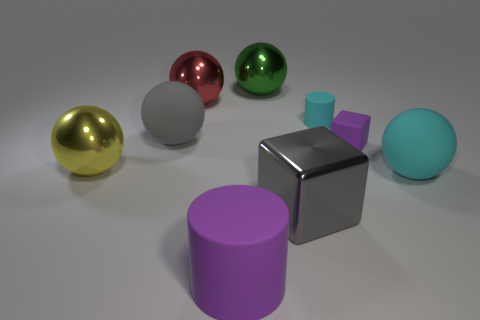Subtract all large yellow metallic balls. How many balls are left? 4 Subtract 3 spheres. How many spheres are left? 2 Subtract all cyan spheres. How many spheres are left? 4 Subtract all yellow balls. Subtract all gray cubes. How many balls are left? 4 Subtract all large cyan rubber spheres. Subtract all cyan cylinders. How many objects are left? 7 Add 4 big red shiny things. How many big red shiny things are left? 5 Add 8 large gray balls. How many large gray balls exist? 9 Subtract 1 red balls. How many objects are left? 8 Subtract all balls. How many objects are left? 4 